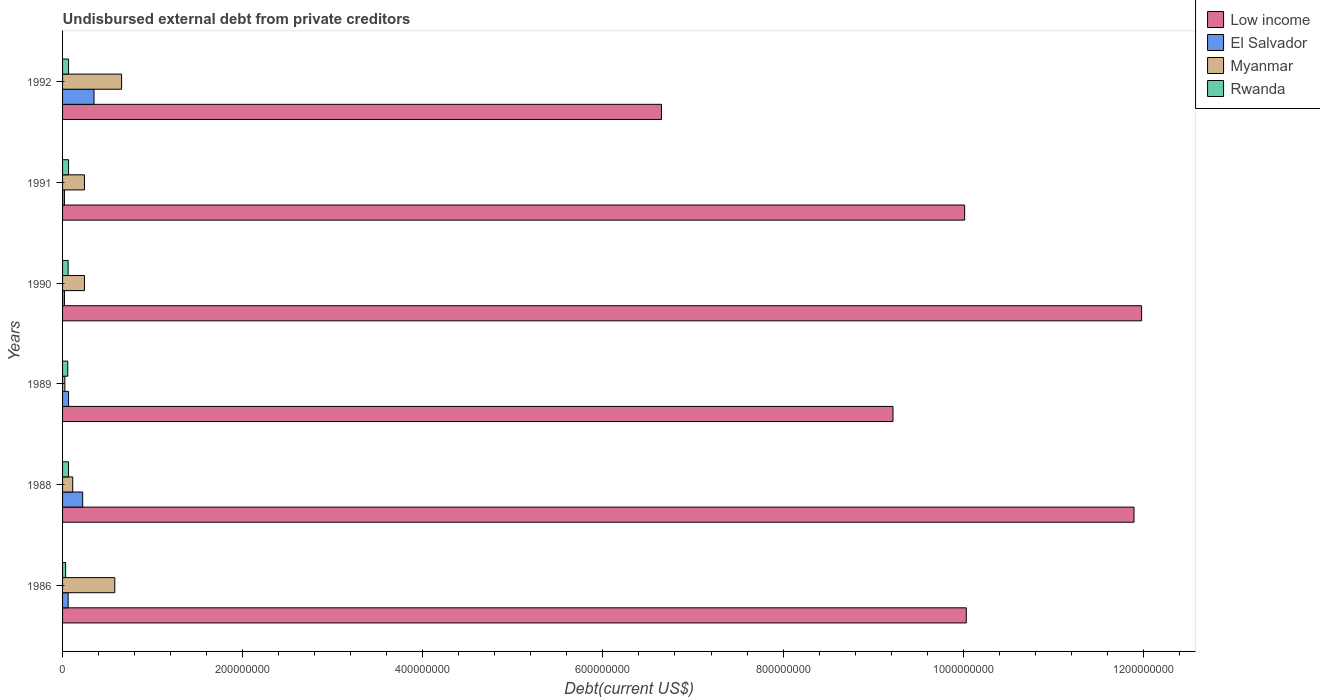How many different coloured bars are there?
Keep it short and to the point. 4. Are the number of bars per tick equal to the number of legend labels?
Your response must be concise. Yes. Are the number of bars on each tick of the Y-axis equal?
Provide a short and direct response. Yes. How many bars are there on the 6th tick from the top?
Offer a terse response. 4. How many bars are there on the 4th tick from the bottom?
Your answer should be compact. 4. What is the label of the 6th group of bars from the top?
Provide a succinct answer. 1986. What is the total debt in Myanmar in 1988?
Provide a short and direct response. 1.13e+07. Across all years, what is the maximum total debt in Rwanda?
Keep it short and to the point. 6.66e+06. Across all years, what is the minimum total debt in Myanmar?
Keep it short and to the point. 2.54e+06. In which year was the total debt in Rwanda maximum?
Provide a succinct answer. 1992. In which year was the total debt in Rwanda minimum?
Offer a terse response. 1986. What is the total total debt in El Salvador in the graph?
Your answer should be very brief. 7.43e+07. What is the difference between the total debt in Myanmar in 1990 and the total debt in El Salvador in 1992?
Offer a terse response. -1.06e+07. What is the average total debt in El Salvador per year?
Your answer should be compact. 1.24e+07. In the year 1992, what is the difference between the total debt in Rwanda and total debt in El Salvador?
Your answer should be compact. -2.83e+07. In how many years, is the total debt in El Salvador greater than 880000000 US$?
Make the answer very short. 0. What is the ratio of the total debt in Myanmar in 1989 to that in 1991?
Keep it short and to the point. 0.1. Is the total debt in Low income in 1988 less than that in 1990?
Your response must be concise. Yes. Is the difference between the total debt in Rwanda in 1988 and 1990 greater than the difference between the total debt in El Salvador in 1988 and 1990?
Your answer should be compact. No. What is the difference between the highest and the second highest total debt in Myanmar?
Offer a very short reply. 7.57e+06. What is the difference between the highest and the lowest total debt in Rwanda?
Keep it short and to the point. 3.24e+06. How many bars are there?
Your answer should be compact. 24. How are the legend labels stacked?
Your answer should be very brief. Vertical. What is the title of the graph?
Provide a succinct answer. Undisbursed external debt from private creditors. What is the label or title of the X-axis?
Offer a terse response. Debt(current US$). What is the Debt(current US$) in Low income in 1986?
Offer a very short reply. 1.00e+09. What is the Debt(current US$) in El Salvador in 1986?
Give a very brief answer. 6.21e+06. What is the Debt(current US$) of Myanmar in 1986?
Keep it short and to the point. 5.80e+07. What is the Debt(current US$) in Rwanda in 1986?
Offer a very short reply. 3.42e+06. What is the Debt(current US$) of Low income in 1988?
Your answer should be compact. 1.19e+09. What is the Debt(current US$) of El Salvador in 1988?
Offer a terse response. 2.24e+07. What is the Debt(current US$) in Myanmar in 1988?
Your answer should be very brief. 1.13e+07. What is the Debt(current US$) in Rwanda in 1988?
Keep it short and to the point. 6.60e+06. What is the Debt(current US$) of Low income in 1989?
Your answer should be compact. 9.22e+08. What is the Debt(current US$) of El Salvador in 1989?
Offer a very short reply. 6.67e+06. What is the Debt(current US$) of Myanmar in 1989?
Ensure brevity in your answer.  2.54e+06. What is the Debt(current US$) of Rwanda in 1989?
Ensure brevity in your answer.  5.79e+06. What is the Debt(current US$) of Low income in 1990?
Your response must be concise. 1.20e+09. What is the Debt(current US$) in El Salvador in 1990?
Offer a terse response. 2.08e+06. What is the Debt(current US$) in Myanmar in 1990?
Your answer should be very brief. 2.43e+07. What is the Debt(current US$) of Rwanda in 1990?
Offer a very short reply. 6.18e+06. What is the Debt(current US$) of Low income in 1991?
Give a very brief answer. 1.00e+09. What is the Debt(current US$) of El Salvador in 1991?
Offer a very short reply. 2.06e+06. What is the Debt(current US$) of Myanmar in 1991?
Keep it short and to the point. 2.43e+07. What is the Debt(current US$) of Rwanda in 1991?
Keep it short and to the point. 6.64e+06. What is the Debt(current US$) of Low income in 1992?
Offer a very short reply. 6.65e+08. What is the Debt(current US$) in El Salvador in 1992?
Give a very brief answer. 3.49e+07. What is the Debt(current US$) in Myanmar in 1992?
Your answer should be compact. 6.56e+07. What is the Debt(current US$) in Rwanda in 1992?
Provide a short and direct response. 6.66e+06. Across all years, what is the maximum Debt(current US$) in Low income?
Provide a short and direct response. 1.20e+09. Across all years, what is the maximum Debt(current US$) in El Salvador?
Give a very brief answer. 3.49e+07. Across all years, what is the maximum Debt(current US$) of Myanmar?
Your answer should be very brief. 6.56e+07. Across all years, what is the maximum Debt(current US$) of Rwanda?
Your response must be concise. 6.66e+06. Across all years, what is the minimum Debt(current US$) of Low income?
Your response must be concise. 6.65e+08. Across all years, what is the minimum Debt(current US$) in El Salvador?
Provide a succinct answer. 2.06e+06. Across all years, what is the minimum Debt(current US$) of Myanmar?
Offer a terse response. 2.54e+06. Across all years, what is the minimum Debt(current US$) of Rwanda?
Offer a terse response. 3.42e+06. What is the total Debt(current US$) in Low income in the graph?
Your answer should be compact. 5.98e+09. What is the total Debt(current US$) in El Salvador in the graph?
Your answer should be compact. 7.43e+07. What is the total Debt(current US$) of Myanmar in the graph?
Provide a short and direct response. 1.86e+08. What is the total Debt(current US$) in Rwanda in the graph?
Your response must be concise. 3.53e+07. What is the difference between the Debt(current US$) in Low income in 1986 and that in 1988?
Your answer should be very brief. -1.86e+08. What is the difference between the Debt(current US$) of El Salvador in 1986 and that in 1988?
Make the answer very short. -1.61e+07. What is the difference between the Debt(current US$) of Myanmar in 1986 and that in 1988?
Provide a succinct answer. 4.67e+07. What is the difference between the Debt(current US$) of Rwanda in 1986 and that in 1988?
Your answer should be compact. -3.18e+06. What is the difference between the Debt(current US$) in Low income in 1986 and that in 1989?
Offer a terse response. 8.14e+07. What is the difference between the Debt(current US$) in El Salvador in 1986 and that in 1989?
Provide a succinct answer. -4.62e+05. What is the difference between the Debt(current US$) of Myanmar in 1986 and that in 1989?
Provide a succinct answer. 5.54e+07. What is the difference between the Debt(current US$) of Rwanda in 1986 and that in 1989?
Provide a short and direct response. -2.37e+06. What is the difference between the Debt(current US$) in Low income in 1986 and that in 1990?
Offer a very short reply. -1.95e+08. What is the difference between the Debt(current US$) in El Salvador in 1986 and that in 1990?
Provide a succinct answer. 4.13e+06. What is the difference between the Debt(current US$) in Myanmar in 1986 and that in 1990?
Ensure brevity in your answer.  3.37e+07. What is the difference between the Debt(current US$) of Rwanda in 1986 and that in 1990?
Your answer should be very brief. -2.76e+06. What is the difference between the Debt(current US$) of Low income in 1986 and that in 1991?
Your answer should be very brief. 1.83e+06. What is the difference between the Debt(current US$) in El Salvador in 1986 and that in 1991?
Ensure brevity in your answer.  4.15e+06. What is the difference between the Debt(current US$) in Myanmar in 1986 and that in 1991?
Your answer should be compact. 3.37e+07. What is the difference between the Debt(current US$) of Rwanda in 1986 and that in 1991?
Your answer should be compact. -3.22e+06. What is the difference between the Debt(current US$) in Low income in 1986 and that in 1992?
Give a very brief answer. 3.38e+08. What is the difference between the Debt(current US$) of El Salvador in 1986 and that in 1992?
Keep it short and to the point. -2.87e+07. What is the difference between the Debt(current US$) of Myanmar in 1986 and that in 1992?
Ensure brevity in your answer.  -7.57e+06. What is the difference between the Debt(current US$) of Rwanda in 1986 and that in 1992?
Your answer should be compact. -3.24e+06. What is the difference between the Debt(current US$) of Low income in 1988 and that in 1989?
Provide a short and direct response. 2.68e+08. What is the difference between the Debt(current US$) in El Salvador in 1988 and that in 1989?
Your response must be concise. 1.57e+07. What is the difference between the Debt(current US$) of Myanmar in 1988 and that in 1989?
Provide a succinct answer. 8.74e+06. What is the difference between the Debt(current US$) of Rwanda in 1988 and that in 1989?
Offer a terse response. 8.10e+05. What is the difference between the Debt(current US$) of Low income in 1988 and that in 1990?
Offer a very short reply. -8.44e+06. What is the difference between the Debt(current US$) of El Salvador in 1988 and that in 1990?
Keep it short and to the point. 2.03e+07. What is the difference between the Debt(current US$) in Myanmar in 1988 and that in 1990?
Your answer should be very brief. -1.30e+07. What is the difference between the Debt(current US$) of Low income in 1988 and that in 1991?
Keep it short and to the point. 1.88e+08. What is the difference between the Debt(current US$) in El Salvador in 1988 and that in 1991?
Ensure brevity in your answer.  2.03e+07. What is the difference between the Debt(current US$) of Myanmar in 1988 and that in 1991?
Provide a short and direct response. -1.30e+07. What is the difference between the Debt(current US$) of Rwanda in 1988 and that in 1991?
Keep it short and to the point. -3.40e+04. What is the difference between the Debt(current US$) in Low income in 1988 and that in 1992?
Offer a terse response. 5.25e+08. What is the difference between the Debt(current US$) in El Salvador in 1988 and that in 1992?
Make the answer very short. -1.26e+07. What is the difference between the Debt(current US$) of Myanmar in 1988 and that in 1992?
Offer a terse response. -5.43e+07. What is the difference between the Debt(current US$) in Rwanda in 1988 and that in 1992?
Your answer should be compact. -5.80e+04. What is the difference between the Debt(current US$) of Low income in 1989 and that in 1990?
Your response must be concise. -2.76e+08. What is the difference between the Debt(current US$) of El Salvador in 1989 and that in 1990?
Provide a succinct answer. 4.59e+06. What is the difference between the Debt(current US$) in Myanmar in 1989 and that in 1990?
Provide a succinct answer. -2.18e+07. What is the difference between the Debt(current US$) of Rwanda in 1989 and that in 1990?
Your response must be concise. -3.90e+05. What is the difference between the Debt(current US$) of Low income in 1989 and that in 1991?
Your answer should be compact. -7.96e+07. What is the difference between the Debt(current US$) in El Salvador in 1989 and that in 1991?
Your answer should be very brief. 4.61e+06. What is the difference between the Debt(current US$) in Myanmar in 1989 and that in 1991?
Offer a very short reply. -2.18e+07. What is the difference between the Debt(current US$) of Rwanda in 1989 and that in 1991?
Ensure brevity in your answer.  -8.44e+05. What is the difference between the Debt(current US$) of Low income in 1989 and that in 1992?
Keep it short and to the point. 2.57e+08. What is the difference between the Debt(current US$) in El Salvador in 1989 and that in 1992?
Your answer should be very brief. -2.83e+07. What is the difference between the Debt(current US$) in Myanmar in 1989 and that in 1992?
Give a very brief answer. -6.30e+07. What is the difference between the Debt(current US$) in Rwanda in 1989 and that in 1992?
Give a very brief answer. -8.68e+05. What is the difference between the Debt(current US$) of Low income in 1990 and that in 1991?
Keep it short and to the point. 1.96e+08. What is the difference between the Debt(current US$) in El Salvador in 1990 and that in 1991?
Your response must be concise. 2.10e+04. What is the difference between the Debt(current US$) in Myanmar in 1990 and that in 1991?
Ensure brevity in your answer.  0. What is the difference between the Debt(current US$) of Rwanda in 1990 and that in 1991?
Provide a succinct answer. -4.54e+05. What is the difference between the Debt(current US$) in Low income in 1990 and that in 1992?
Offer a terse response. 5.33e+08. What is the difference between the Debt(current US$) of El Salvador in 1990 and that in 1992?
Your answer should be compact. -3.28e+07. What is the difference between the Debt(current US$) in Myanmar in 1990 and that in 1992?
Your response must be concise. -4.12e+07. What is the difference between the Debt(current US$) in Rwanda in 1990 and that in 1992?
Your response must be concise. -4.78e+05. What is the difference between the Debt(current US$) in Low income in 1991 and that in 1992?
Give a very brief answer. 3.37e+08. What is the difference between the Debt(current US$) in El Salvador in 1991 and that in 1992?
Provide a short and direct response. -3.29e+07. What is the difference between the Debt(current US$) of Myanmar in 1991 and that in 1992?
Your answer should be compact. -4.12e+07. What is the difference between the Debt(current US$) of Rwanda in 1991 and that in 1992?
Make the answer very short. -2.40e+04. What is the difference between the Debt(current US$) in Low income in 1986 and the Debt(current US$) in El Salvador in 1988?
Your answer should be very brief. 9.81e+08. What is the difference between the Debt(current US$) in Low income in 1986 and the Debt(current US$) in Myanmar in 1988?
Offer a very short reply. 9.92e+08. What is the difference between the Debt(current US$) in Low income in 1986 and the Debt(current US$) in Rwanda in 1988?
Offer a very short reply. 9.97e+08. What is the difference between the Debt(current US$) in El Salvador in 1986 and the Debt(current US$) in Myanmar in 1988?
Provide a succinct answer. -5.07e+06. What is the difference between the Debt(current US$) of El Salvador in 1986 and the Debt(current US$) of Rwanda in 1988?
Offer a terse response. -3.97e+05. What is the difference between the Debt(current US$) in Myanmar in 1986 and the Debt(current US$) in Rwanda in 1988?
Provide a short and direct response. 5.14e+07. What is the difference between the Debt(current US$) of Low income in 1986 and the Debt(current US$) of El Salvador in 1989?
Provide a succinct answer. 9.97e+08. What is the difference between the Debt(current US$) of Low income in 1986 and the Debt(current US$) of Myanmar in 1989?
Offer a very short reply. 1.00e+09. What is the difference between the Debt(current US$) in Low income in 1986 and the Debt(current US$) in Rwanda in 1989?
Offer a terse response. 9.98e+08. What is the difference between the Debt(current US$) in El Salvador in 1986 and the Debt(current US$) in Myanmar in 1989?
Your answer should be very brief. 3.67e+06. What is the difference between the Debt(current US$) in El Salvador in 1986 and the Debt(current US$) in Rwanda in 1989?
Provide a short and direct response. 4.13e+05. What is the difference between the Debt(current US$) in Myanmar in 1986 and the Debt(current US$) in Rwanda in 1989?
Provide a succinct answer. 5.22e+07. What is the difference between the Debt(current US$) in Low income in 1986 and the Debt(current US$) in El Salvador in 1990?
Keep it short and to the point. 1.00e+09. What is the difference between the Debt(current US$) of Low income in 1986 and the Debt(current US$) of Myanmar in 1990?
Ensure brevity in your answer.  9.79e+08. What is the difference between the Debt(current US$) of Low income in 1986 and the Debt(current US$) of Rwanda in 1990?
Your response must be concise. 9.97e+08. What is the difference between the Debt(current US$) in El Salvador in 1986 and the Debt(current US$) in Myanmar in 1990?
Keep it short and to the point. -1.81e+07. What is the difference between the Debt(current US$) of El Salvador in 1986 and the Debt(current US$) of Rwanda in 1990?
Provide a short and direct response. 2.30e+04. What is the difference between the Debt(current US$) in Myanmar in 1986 and the Debt(current US$) in Rwanda in 1990?
Your answer should be very brief. 5.18e+07. What is the difference between the Debt(current US$) of Low income in 1986 and the Debt(current US$) of El Salvador in 1991?
Your answer should be very brief. 1.00e+09. What is the difference between the Debt(current US$) of Low income in 1986 and the Debt(current US$) of Myanmar in 1991?
Your answer should be very brief. 9.79e+08. What is the difference between the Debt(current US$) of Low income in 1986 and the Debt(current US$) of Rwanda in 1991?
Ensure brevity in your answer.  9.97e+08. What is the difference between the Debt(current US$) of El Salvador in 1986 and the Debt(current US$) of Myanmar in 1991?
Provide a succinct answer. -1.81e+07. What is the difference between the Debt(current US$) of El Salvador in 1986 and the Debt(current US$) of Rwanda in 1991?
Offer a very short reply. -4.31e+05. What is the difference between the Debt(current US$) in Myanmar in 1986 and the Debt(current US$) in Rwanda in 1991?
Your response must be concise. 5.13e+07. What is the difference between the Debt(current US$) of Low income in 1986 and the Debt(current US$) of El Salvador in 1992?
Provide a short and direct response. 9.69e+08. What is the difference between the Debt(current US$) in Low income in 1986 and the Debt(current US$) in Myanmar in 1992?
Provide a short and direct response. 9.38e+08. What is the difference between the Debt(current US$) of Low income in 1986 and the Debt(current US$) of Rwanda in 1992?
Your answer should be compact. 9.97e+08. What is the difference between the Debt(current US$) of El Salvador in 1986 and the Debt(current US$) of Myanmar in 1992?
Provide a short and direct response. -5.93e+07. What is the difference between the Debt(current US$) of El Salvador in 1986 and the Debt(current US$) of Rwanda in 1992?
Provide a short and direct response. -4.55e+05. What is the difference between the Debt(current US$) of Myanmar in 1986 and the Debt(current US$) of Rwanda in 1992?
Your answer should be very brief. 5.13e+07. What is the difference between the Debt(current US$) of Low income in 1988 and the Debt(current US$) of El Salvador in 1989?
Provide a succinct answer. 1.18e+09. What is the difference between the Debt(current US$) of Low income in 1988 and the Debt(current US$) of Myanmar in 1989?
Your response must be concise. 1.19e+09. What is the difference between the Debt(current US$) of Low income in 1988 and the Debt(current US$) of Rwanda in 1989?
Ensure brevity in your answer.  1.18e+09. What is the difference between the Debt(current US$) of El Salvador in 1988 and the Debt(current US$) of Myanmar in 1989?
Your answer should be very brief. 1.98e+07. What is the difference between the Debt(current US$) of El Salvador in 1988 and the Debt(current US$) of Rwanda in 1989?
Give a very brief answer. 1.66e+07. What is the difference between the Debt(current US$) of Myanmar in 1988 and the Debt(current US$) of Rwanda in 1989?
Your answer should be compact. 5.48e+06. What is the difference between the Debt(current US$) in Low income in 1988 and the Debt(current US$) in El Salvador in 1990?
Your answer should be compact. 1.19e+09. What is the difference between the Debt(current US$) of Low income in 1988 and the Debt(current US$) of Myanmar in 1990?
Give a very brief answer. 1.17e+09. What is the difference between the Debt(current US$) in Low income in 1988 and the Debt(current US$) in Rwanda in 1990?
Your answer should be compact. 1.18e+09. What is the difference between the Debt(current US$) in El Salvador in 1988 and the Debt(current US$) in Myanmar in 1990?
Your answer should be very brief. -1.94e+06. What is the difference between the Debt(current US$) of El Salvador in 1988 and the Debt(current US$) of Rwanda in 1990?
Give a very brief answer. 1.62e+07. What is the difference between the Debt(current US$) of Myanmar in 1988 and the Debt(current US$) of Rwanda in 1990?
Provide a succinct answer. 5.09e+06. What is the difference between the Debt(current US$) of Low income in 1988 and the Debt(current US$) of El Salvador in 1991?
Make the answer very short. 1.19e+09. What is the difference between the Debt(current US$) of Low income in 1988 and the Debt(current US$) of Myanmar in 1991?
Offer a terse response. 1.17e+09. What is the difference between the Debt(current US$) of Low income in 1988 and the Debt(current US$) of Rwanda in 1991?
Provide a succinct answer. 1.18e+09. What is the difference between the Debt(current US$) of El Salvador in 1988 and the Debt(current US$) of Myanmar in 1991?
Offer a terse response. -1.94e+06. What is the difference between the Debt(current US$) of El Salvador in 1988 and the Debt(current US$) of Rwanda in 1991?
Make the answer very short. 1.57e+07. What is the difference between the Debt(current US$) of Myanmar in 1988 and the Debt(current US$) of Rwanda in 1991?
Provide a short and direct response. 4.64e+06. What is the difference between the Debt(current US$) in Low income in 1988 and the Debt(current US$) in El Salvador in 1992?
Offer a terse response. 1.15e+09. What is the difference between the Debt(current US$) of Low income in 1988 and the Debt(current US$) of Myanmar in 1992?
Offer a very short reply. 1.12e+09. What is the difference between the Debt(current US$) in Low income in 1988 and the Debt(current US$) in Rwanda in 1992?
Make the answer very short. 1.18e+09. What is the difference between the Debt(current US$) in El Salvador in 1988 and the Debt(current US$) in Myanmar in 1992?
Your answer should be very brief. -4.32e+07. What is the difference between the Debt(current US$) of El Salvador in 1988 and the Debt(current US$) of Rwanda in 1992?
Your response must be concise. 1.57e+07. What is the difference between the Debt(current US$) in Myanmar in 1988 and the Debt(current US$) in Rwanda in 1992?
Your response must be concise. 4.62e+06. What is the difference between the Debt(current US$) in Low income in 1989 and the Debt(current US$) in El Salvador in 1990?
Offer a very short reply. 9.20e+08. What is the difference between the Debt(current US$) in Low income in 1989 and the Debt(current US$) in Myanmar in 1990?
Provide a short and direct response. 8.98e+08. What is the difference between the Debt(current US$) of Low income in 1989 and the Debt(current US$) of Rwanda in 1990?
Keep it short and to the point. 9.16e+08. What is the difference between the Debt(current US$) in El Salvador in 1989 and the Debt(current US$) in Myanmar in 1990?
Your answer should be compact. -1.76e+07. What is the difference between the Debt(current US$) of El Salvador in 1989 and the Debt(current US$) of Rwanda in 1990?
Give a very brief answer. 4.85e+05. What is the difference between the Debt(current US$) in Myanmar in 1989 and the Debt(current US$) in Rwanda in 1990?
Ensure brevity in your answer.  -3.64e+06. What is the difference between the Debt(current US$) of Low income in 1989 and the Debt(current US$) of El Salvador in 1991?
Make the answer very short. 9.20e+08. What is the difference between the Debt(current US$) of Low income in 1989 and the Debt(current US$) of Myanmar in 1991?
Your response must be concise. 8.98e+08. What is the difference between the Debt(current US$) of Low income in 1989 and the Debt(current US$) of Rwanda in 1991?
Make the answer very short. 9.15e+08. What is the difference between the Debt(current US$) in El Salvador in 1989 and the Debt(current US$) in Myanmar in 1991?
Give a very brief answer. -1.76e+07. What is the difference between the Debt(current US$) in El Salvador in 1989 and the Debt(current US$) in Rwanda in 1991?
Offer a terse response. 3.10e+04. What is the difference between the Debt(current US$) in Myanmar in 1989 and the Debt(current US$) in Rwanda in 1991?
Give a very brief answer. -4.10e+06. What is the difference between the Debt(current US$) of Low income in 1989 and the Debt(current US$) of El Salvador in 1992?
Your answer should be compact. 8.87e+08. What is the difference between the Debt(current US$) in Low income in 1989 and the Debt(current US$) in Myanmar in 1992?
Keep it short and to the point. 8.57e+08. What is the difference between the Debt(current US$) in Low income in 1989 and the Debt(current US$) in Rwanda in 1992?
Offer a very short reply. 9.15e+08. What is the difference between the Debt(current US$) in El Salvador in 1989 and the Debt(current US$) in Myanmar in 1992?
Your answer should be compact. -5.89e+07. What is the difference between the Debt(current US$) of El Salvador in 1989 and the Debt(current US$) of Rwanda in 1992?
Offer a terse response. 7000. What is the difference between the Debt(current US$) of Myanmar in 1989 and the Debt(current US$) of Rwanda in 1992?
Keep it short and to the point. -4.12e+06. What is the difference between the Debt(current US$) of Low income in 1990 and the Debt(current US$) of El Salvador in 1991?
Ensure brevity in your answer.  1.20e+09. What is the difference between the Debt(current US$) of Low income in 1990 and the Debt(current US$) of Myanmar in 1991?
Your answer should be very brief. 1.17e+09. What is the difference between the Debt(current US$) in Low income in 1990 and the Debt(current US$) in Rwanda in 1991?
Make the answer very short. 1.19e+09. What is the difference between the Debt(current US$) in El Salvador in 1990 and the Debt(current US$) in Myanmar in 1991?
Keep it short and to the point. -2.22e+07. What is the difference between the Debt(current US$) in El Salvador in 1990 and the Debt(current US$) in Rwanda in 1991?
Offer a terse response. -4.56e+06. What is the difference between the Debt(current US$) of Myanmar in 1990 and the Debt(current US$) of Rwanda in 1991?
Provide a short and direct response. 1.77e+07. What is the difference between the Debt(current US$) in Low income in 1990 and the Debt(current US$) in El Salvador in 1992?
Keep it short and to the point. 1.16e+09. What is the difference between the Debt(current US$) of Low income in 1990 and the Debt(current US$) of Myanmar in 1992?
Provide a short and direct response. 1.13e+09. What is the difference between the Debt(current US$) in Low income in 1990 and the Debt(current US$) in Rwanda in 1992?
Ensure brevity in your answer.  1.19e+09. What is the difference between the Debt(current US$) of El Salvador in 1990 and the Debt(current US$) of Myanmar in 1992?
Offer a terse response. -6.35e+07. What is the difference between the Debt(current US$) in El Salvador in 1990 and the Debt(current US$) in Rwanda in 1992?
Provide a short and direct response. -4.58e+06. What is the difference between the Debt(current US$) in Myanmar in 1990 and the Debt(current US$) in Rwanda in 1992?
Your answer should be compact. 1.76e+07. What is the difference between the Debt(current US$) in Low income in 1991 and the Debt(current US$) in El Salvador in 1992?
Offer a terse response. 9.67e+08. What is the difference between the Debt(current US$) in Low income in 1991 and the Debt(current US$) in Myanmar in 1992?
Your response must be concise. 9.36e+08. What is the difference between the Debt(current US$) in Low income in 1991 and the Debt(current US$) in Rwanda in 1992?
Your response must be concise. 9.95e+08. What is the difference between the Debt(current US$) of El Salvador in 1991 and the Debt(current US$) of Myanmar in 1992?
Your answer should be compact. -6.35e+07. What is the difference between the Debt(current US$) of El Salvador in 1991 and the Debt(current US$) of Rwanda in 1992?
Your response must be concise. -4.60e+06. What is the difference between the Debt(current US$) in Myanmar in 1991 and the Debt(current US$) in Rwanda in 1992?
Your answer should be compact. 1.76e+07. What is the average Debt(current US$) in Low income per year?
Offer a very short reply. 9.97e+08. What is the average Debt(current US$) of El Salvador per year?
Ensure brevity in your answer.  1.24e+07. What is the average Debt(current US$) in Myanmar per year?
Your response must be concise. 3.10e+07. What is the average Debt(current US$) in Rwanda per year?
Provide a succinct answer. 5.88e+06. In the year 1986, what is the difference between the Debt(current US$) in Low income and Debt(current US$) in El Salvador?
Offer a very short reply. 9.97e+08. In the year 1986, what is the difference between the Debt(current US$) in Low income and Debt(current US$) in Myanmar?
Offer a terse response. 9.45e+08. In the year 1986, what is the difference between the Debt(current US$) of Low income and Debt(current US$) of Rwanda?
Ensure brevity in your answer.  1.00e+09. In the year 1986, what is the difference between the Debt(current US$) of El Salvador and Debt(current US$) of Myanmar?
Provide a short and direct response. -5.18e+07. In the year 1986, what is the difference between the Debt(current US$) of El Salvador and Debt(current US$) of Rwanda?
Provide a succinct answer. 2.78e+06. In the year 1986, what is the difference between the Debt(current US$) of Myanmar and Debt(current US$) of Rwanda?
Your response must be concise. 5.46e+07. In the year 1988, what is the difference between the Debt(current US$) of Low income and Debt(current US$) of El Salvador?
Your answer should be very brief. 1.17e+09. In the year 1988, what is the difference between the Debt(current US$) in Low income and Debt(current US$) in Myanmar?
Give a very brief answer. 1.18e+09. In the year 1988, what is the difference between the Debt(current US$) in Low income and Debt(current US$) in Rwanda?
Provide a succinct answer. 1.18e+09. In the year 1988, what is the difference between the Debt(current US$) of El Salvador and Debt(current US$) of Myanmar?
Ensure brevity in your answer.  1.11e+07. In the year 1988, what is the difference between the Debt(current US$) in El Salvador and Debt(current US$) in Rwanda?
Keep it short and to the point. 1.58e+07. In the year 1988, what is the difference between the Debt(current US$) of Myanmar and Debt(current US$) of Rwanda?
Provide a short and direct response. 4.67e+06. In the year 1989, what is the difference between the Debt(current US$) of Low income and Debt(current US$) of El Salvador?
Offer a terse response. 9.15e+08. In the year 1989, what is the difference between the Debt(current US$) of Low income and Debt(current US$) of Myanmar?
Your answer should be compact. 9.20e+08. In the year 1989, what is the difference between the Debt(current US$) of Low income and Debt(current US$) of Rwanda?
Keep it short and to the point. 9.16e+08. In the year 1989, what is the difference between the Debt(current US$) in El Salvador and Debt(current US$) in Myanmar?
Provide a succinct answer. 4.13e+06. In the year 1989, what is the difference between the Debt(current US$) of El Salvador and Debt(current US$) of Rwanda?
Keep it short and to the point. 8.75e+05. In the year 1989, what is the difference between the Debt(current US$) of Myanmar and Debt(current US$) of Rwanda?
Keep it short and to the point. -3.25e+06. In the year 1990, what is the difference between the Debt(current US$) in Low income and Debt(current US$) in El Salvador?
Provide a short and direct response. 1.20e+09. In the year 1990, what is the difference between the Debt(current US$) in Low income and Debt(current US$) in Myanmar?
Provide a short and direct response. 1.17e+09. In the year 1990, what is the difference between the Debt(current US$) in Low income and Debt(current US$) in Rwanda?
Your response must be concise. 1.19e+09. In the year 1990, what is the difference between the Debt(current US$) in El Salvador and Debt(current US$) in Myanmar?
Offer a very short reply. -2.22e+07. In the year 1990, what is the difference between the Debt(current US$) of El Salvador and Debt(current US$) of Rwanda?
Make the answer very short. -4.10e+06. In the year 1990, what is the difference between the Debt(current US$) in Myanmar and Debt(current US$) in Rwanda?
Offer a terse response. 1.81e+07. In the year 1991, what is the difference between the Debt(current US$) in Low income and Debt(current US$) in El Salvador?
Offer a terse response. 1.00e+09. In the year 1991, what is the difference between the Debt(current US$) in Low income and Debt(current US$) in Myanmar?
Make the answer very short. 9.77e+08. In the year 1991, what is the difference between the Debt(current US$) of Low income and Debt(current US$) of Rwanda?
Give a very brief answer. 9.95e+08. In the year 1991, what is the difference between the Debt(current US$) of El Salvador and Debt(current US$) of Myanmar?
Provide a succinct answer. -2.22e+07. In the year 1991, what is the difference between the Debt(current US$) of El Salvador and Debt(current US$) of Rwanda?
Keep it short and to the point. -4.58e+06. In the year 1991, what is the difference between the Debt(current US$) in Myanmar and Debt(current US$) in Rwanda?
Provide a succinct answer. 1.77e+07. In the year 1992, what is the difference between the Debt(current US$) of Low income and Debt(current US$) of El Salvador?
Offer a very short reply. 6.30e+08. In the year 1992, what is the difference between the Debt(current US$) in Low income and Debt(current US$) in Myanmar?
Ensure brevity in your answer.  5.99e+08. In the year 1992, what is the difference between the Debt(current US$) in Low income and Debt(current US$) in Rwanda?
Your answer should be compact. 6.58e+08. In the year 1992, what is the difference between the Debt(current US$) of El Salvador and Debt(current US$) of Myanmar?
Your answer should be compact. -3.06e+07. In the year 1992, what is the difference between the Debt(current US$) of El Salvador and Debt(current US$) of Rwanda?
Your response must be concise. 2.83e+07. In the year 1992, what is the difference between the Debt(current US$) in Myanmar and Debt(current US$) in Rwanda?
Your answer should be very brief. 5.89e+07. What is the ratio of the Debt(current US$) of Low income in 1986 to that in 1988?
Your answer should be compact. 0.84. What is the ratio of the Debt(current US$) of El Salvador in 1986 to that in 1988?
Ensure brevity in your answer.  0.28. What is the ratio of the Debt(current US$) of Myanmar in 1986 to that in 1988?
Offer a terse response. 5.14. What is the ratio of the Debt(current US$) in Rwanda in 1986 to that in 1988?
Your answer should be compact. 0.52. What is the ratio of the Debt(current US$) of Low income in 1986 to that in 1989?
Offer a very short reply. 1.09. What is the ratio of the Debt(current US$) of El Salvador in 1986 to that in 1989?
Give a very brief answer. 0.93. What is the ratio of the Debt(current US$) in Myanmar in 1986 to that in 1989?
Your answer should be very brief. 22.84. What is the ratio of the Debt(current US$) of Rwanda in 1986 to that in 1989?
Offer a very short reply. 0.59. What is the ratio of the Debt(current US$) in Low income in 1986 to that in 1990?
Offer a very short reply. 0.84. What is the ratio of the Debt(current US$) of El Salvador in 1986 to that in 1990?
Provide a succinct answer. 2.98. What is the ratio of the Debt(current US$) of Myanmar in 1986 to that in 1990?
Ensure brevity in your answer.  2.39. What is the ratio of the Debt(current US$) in Rwanda in 1986 to that in 1990?
Your answer should be very brief. 0.55. What is the ratio of the Debt(current US$) in El Salvador in 1986 to that in 1991?
Your answer should be very brief. 3.01. What is the ratio of the Debt(current US$) in Myanmar in 1986 to that in 1991?
Ensure brevity in your answer.  2.39. What is the ratio of the Debt(current US$) of Rwanda in 1986 to that in 1991?
Provide a succinct answer. 0.52. What is the ratio of the Debt(current US$) of Low income in 1986 to that in 1992?
Keep it short and to the point. 1.51. What is the ratio of the Debt(current US$) in El Salvador in 1986 to that in 1992?
Your response must be concise. 0.18. What is the ratio of the Debt(current US$) in Myanmar in 1986 to that in 1992?
Provide a short and direct response. 0.88. What is the ratio of the Debt(current US$) of Rwanda in 1986 to that in 1992?
Ensure brevity in your answer.  0.51. What is the ratio of the Debt(current US$) of Low income in 1988 to that in 1989?
Provide a succinct answer. 1.29. What is the ratio of the Debt(current US$) of El Salvador in 1988 to that in 1989?
Your answer should be very brief. 3.35. What is the ratio of the Debt(current US$) in Myanmar in 1988 to that in 1989?
Ensure brevity in your answer.  4.44. What is the ratio of the Debt(current US$) of Rwanda in 1988 to that in 1989?
Offer a terse response. 1.14. What is the ratio of the Debt(current US$) in Low income in 1988 to that in 1990?
Keep it short and to the point. 0.99. What is the ratio of the Debt(current US$) in El Salvador in 1988 to that in 1990?
Ensure brevity in your answer.  10.75. What is the ratio of the Debt(current US$) in Myanmar in 1988 to that in 1990?
Offer a terse response. 0.46. What is the ratio of the Debt(current US$) of Rwanda in 1988 to that in 1990?
Give a very brief answer. 1.07. What is the ratio of the Debt(current US$) in Low income in 1988 to that in 1991?
Offer a terse response. 1.19. What is the ratio of the Debt(current US$) of El Salvador in 1988 to that in 1991?
Your answer should be very brief. 10.86. What is the ratio of the Debt(current US$) of Myanmar in 1988 to that in 1991?
Your answer should be very brief. 0.46. What is the ratio of the Debt(current US$) of Rwanda in 1988 to that in 1991?
Give a very brief answer. 0.99. What is the ratio of the Debt(current US$) in Low income in 1988 to that in 1992?
Give a very brief answer. 1.79. What is the ratio of the Debt(current US$) of El Salvador in 1988 to that in 1992?
Offer a very short reply. 0.64. What is the ratio of the Debt(current US$) of Myanmar in 1988 to that in 1992?
Offer a very short reply. 0.17. What is the ratio of the Debt(current US$) of Low income in 1989 to that in 1990?
Make the answer very short. 0.77. What is the ratio of the Debt(current US$) of El Salvador in 1989 to that in 1990?
Your response must be concise. 3.21. What is the ratio of the Debt(current US$) in Myanmar in 1989 to that in 1990?
Offer a very short reply. 0.1. What is the ratio of the Debt(current US$) of Rwanda in 1989 to that in 1990?
Ensure brevity in your answer.  0.94. What is the ratio of the Debt(current US$) of Low income in 1989 to that in 1991?
Offer a very short reply. 0.92. What is the ratio of the Debt(current US$) in El Salvador in 1989 to that in 1991?
Your response must be concise. 3.24. What is the ratio of the Debt(current US$) of Myanmar in 1989 to that in 1991?
Ensure brevity in your answer.  0.1. What is the ratio of the Debt(current US$) of Rwanda in 1989 to that in 1991?
Make the answer very short. 0.87. What is the ratio of the Debt(current US$) in Low income in 1989 to that in 1992?
Your answer should be compact. 1.39. What is the ratio of the Debt(current US$) of El Salvador in 1989 to that in 1992?
Your answer should be compact. 0.19. What is the ratio of the Debt(current US$) in Myanmar in 1989 to that in 1992?
Your response must be concise. 0.04. What is the ratio of the Debt(current US$) in Rwanda in 1989 to that in 1992?
Offer a terse response. 0.87. What is the ratio of the Debt(current US$) of Low income in 1990 to that in 1991?
Give a very brief answer. 1.2. What is the ratio of the Debt(current US$) of El Salvador in 1990 to that in 1991?
Offer a very short reply. 1.01. What is the ratio of the Debt(current US$) of Rwanda in 1990 to that in 1991?
Your response must be concise. 0.93. What is the ratio of the Debt(current US$) in Low income in 1990 to that in 1992?
Provide a short and direct response. 1.8. What is the ratio of the Debt(current US$) in El Salvador in 1990 to that in 1992?
Offer a terse response. 0.06. What is the ratio of the Debt(current US$) in Myanmar in 1990 to that in 1992?
Your answer should be very brief. 0.37. What is the ratio of the Debt(current US$) of Rwanda in 1990 to that in 1992?
Ensure brevity in your answer.  0.93. What is the ratio of the Debt(current US$) of Low income in 1991 to that in 1992?
Your response must be concise. 1.51. What is the ratio of the Debt(current US$) in El Salvador in 1991 to that in 1992?
Offer a very short reply. 0.06. What is the ratio of the Debt(current US$) of Myanmar in 1991 to that in 1992?
Your response must be concise. 0.37. What is the ratio of the Debt(current US$) of Rwanda in 1991 to that in 1992?
Make the answer very short. 1. What is the difference between the highest and the second highest Debt(current US$) in Low income?
Provide a short and direct response. 8.44e+06. What is the difference between the highest and the second highest Debt(current US$) in El Salvador?
Your answer should be very brief. 1.26e+07. What is the difference between the highest and the second highest Debt(current US$) in Myanmar?
Ensure brevity in your answer.  7.57e+06. What is the difference between the highest and the second highest Debt(current US$) in Rwanda?
Your response must be concise. 2.40e+04. What is the difference between the highest and the lowest Debt(current US$) of Low income?
Keep it short and to the point. 5.33e+08. What is the difference between the highest and the lowest Debt(current US$) of El Salvador?
Make the answer very short. 3.29e+07. What is the difference between the highest and the lowest Debt(current US$) of Myanmar?
Keep it short and to the point. 6.30e+07. What is the difference between the highest and the lowest Debt(current US$) of Rwanda?
Provide a succinct answer. 3.24e+06. 